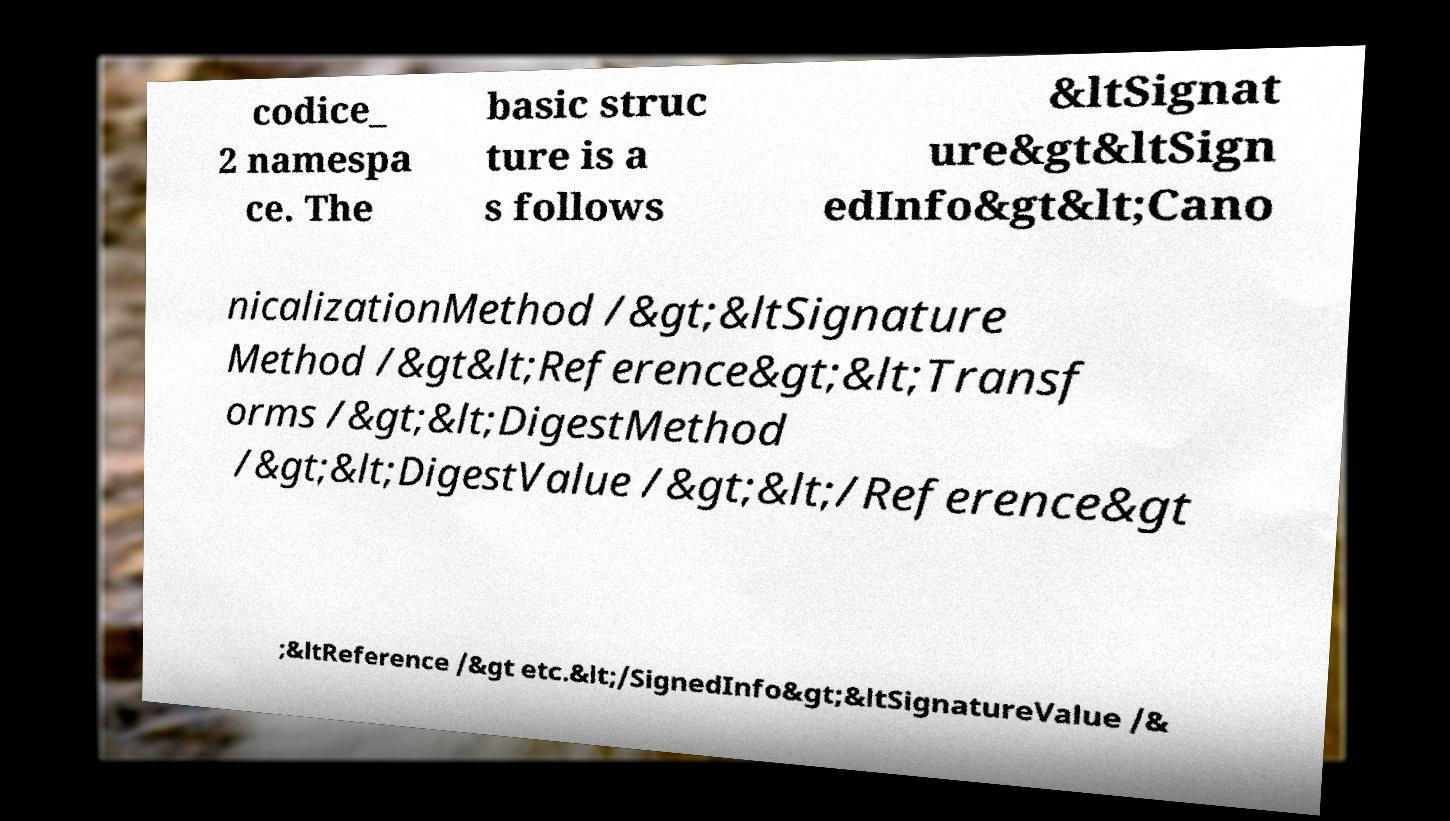For documentation purposes, I need the text within this image transcribed. Could you provide that? codice_ 2 namespa ce. The basic struc ture is a s follows &ltSignat ure&gt&ltSign edInfo&gt&lt;Cano nicalizationMethod /&gt;&ltSignature Method /&gt&lt;Reference&gt;&lt;Transf orms /&gt;&lt;DigestMethod /&gt;&lt;DigestValue /&gt;&lt;/Reference&gt ;&ltReference /&gt etc.&lt;/SignedInfo&gt;&ltSignatureValue /& 